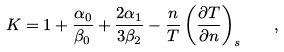<formula> <loc_0><loc_0><loc_500><loc_500>K = 1 + \frac { \alpha _ { 0 } } { \beta _ { 0 } } + \frac { 2 \alpha _ { 1 } } { 3 \beta _ { 2 } } - \frac { n } { T } \left ( \frac { \partial T } { \partial n } \right ) _ { s } \quad ,</formula> 